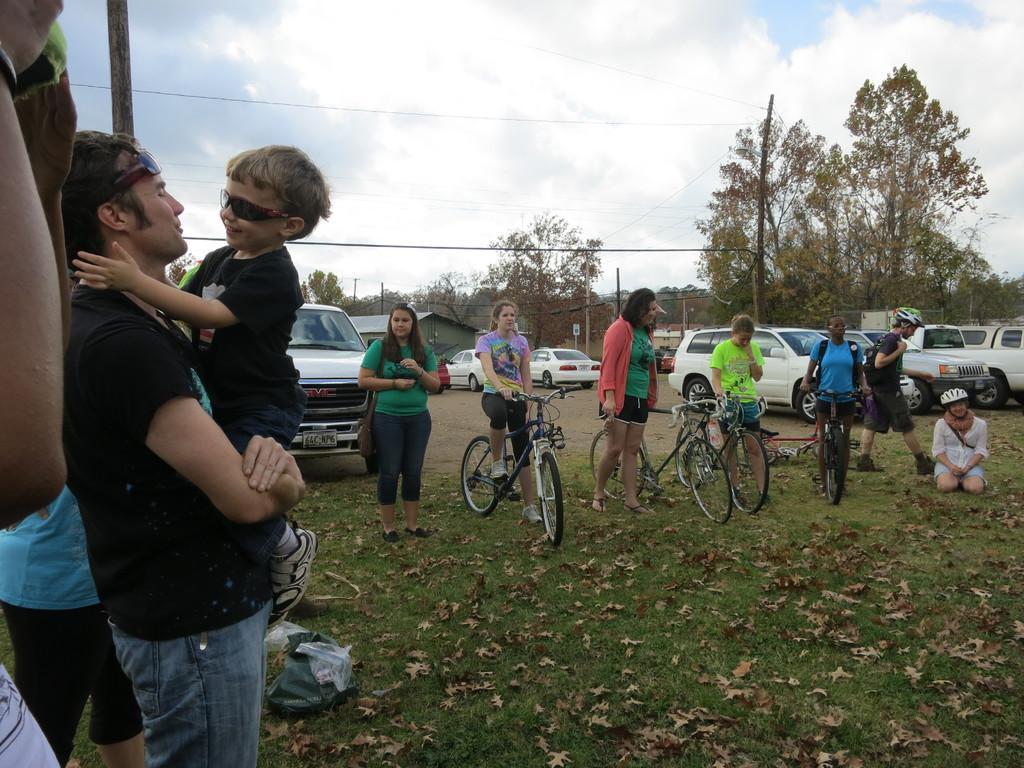How would you summarize this image in a sentence or two? at the left side of the image there are people standing. at the right there are people standing and holding bicycles. behind them there are many cars. behind the cars there are many trees. 